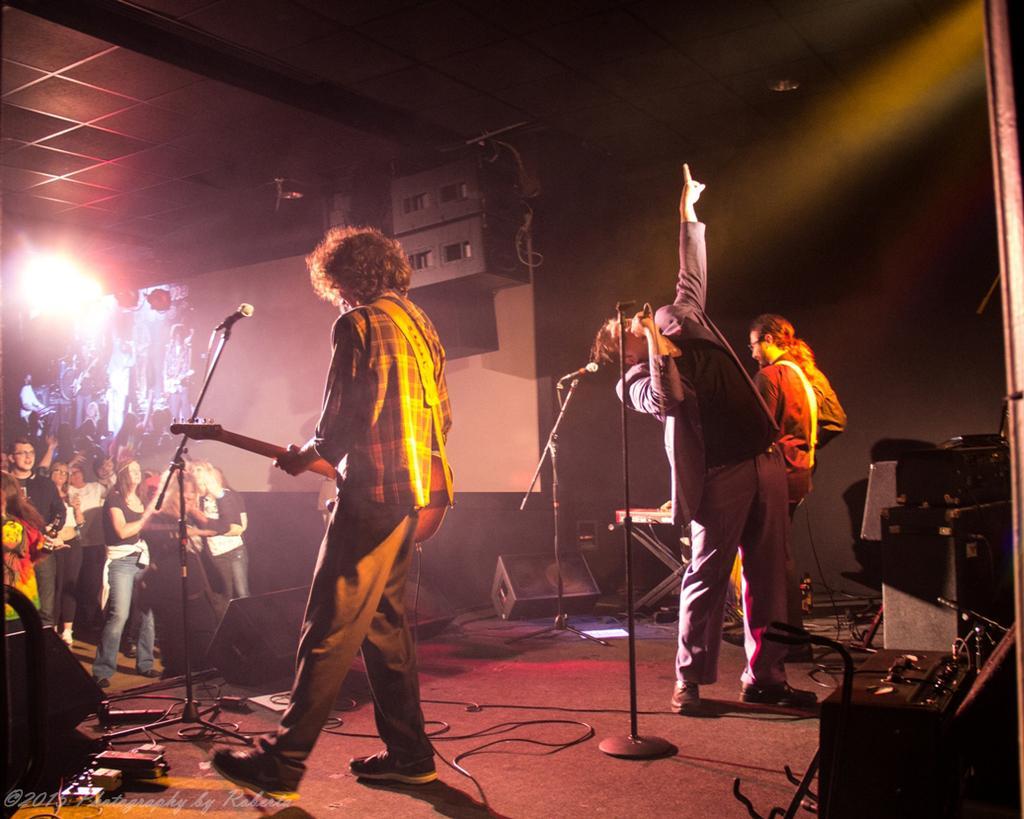In one or two sentences, can you explain what this image depicts? This picture describes about group of people, in the left side of the given image a man is playing guitar in front of the microphone, in the right side of the image a man is singing with the help of microphone, in the background we can see couple of musical instruments. 